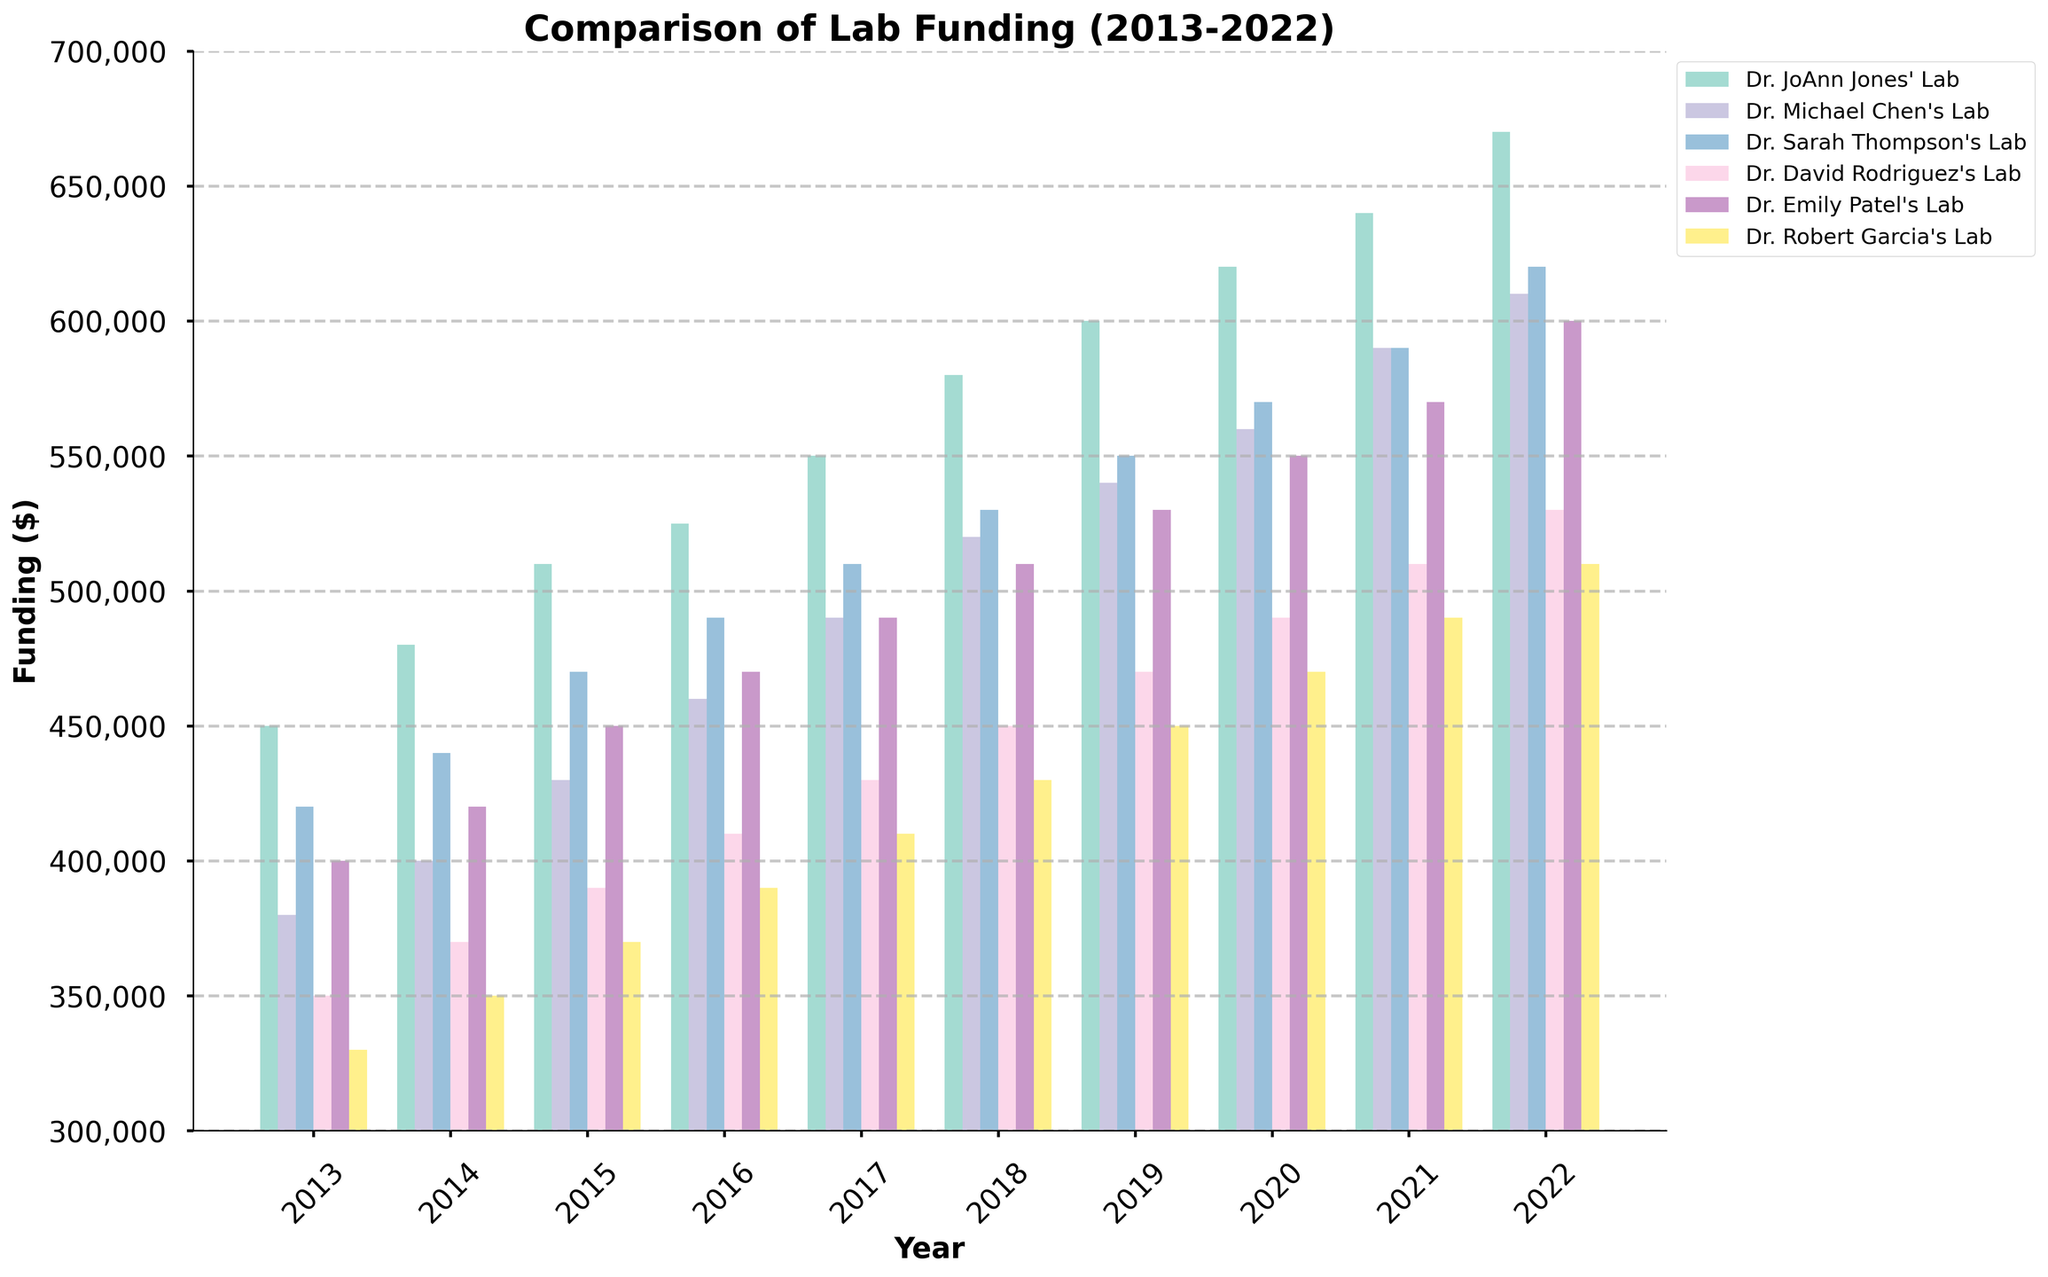Which lab received the highest amount of funding in 2022? To determine this, look at the bars corresponding to 2022 and identify the tallest bar. Dr. JoAnn Jones' Lab has the tallest bar in 2022.
Answer: Dr. JoAnn Jones' Lab Between which two years did Dr. JoAnn Jones' Lab experience the largest increase in funding? Subtract the funding amount for each year from the funding amount for the following year, then find the largest difference. The largest increase is between 2017 and 2018 (580,000 - 550,000 = 30,000).
Answer: 2017 and 2018 What is the average annual funding received by Dr. Robert Garcia's Lab from 2013 to 2022? Sum the funding amounts for each year (330,000 + 350,000 + 370,000 + 390,000 + 410,000 + 430,000 + 450,000 + 470,000 + 490,000 + 510,000 = 4,100,000) and divide by the number of years (10).
Answer: 410,000 How does the funding received by Dr. Michael Chen's Lab in 2020 compare to that of Dr. Emily Patel's Lab in the same year? Look at the bars for 2020 for both labs; Dr. Michael Chen's Lab received 560,000, while Dr. Emily Patel's Lab received 550,000.
Answer: Greater What is the total funding received by Dr. Sarah Thompson's Lab over the entire decade? Sum the funding amounts for each year from 2013 to 2022 (420,000 + 440,000 + 470,000 + 490,000 + 510,000 + 530,000 + 550,000 + 570,000 + 590,000 + 620,000 = 5,190,000).
Answer: 5,190,000 In which year did Dr. David Rodriguez's Lab receive exactly 470,000 in funding? Look at the bars for Dr. David Rodriguez's Lab and identify the year corresponding to the bar height of 470,000. It is in 2019.
Answer: 2019 How did the funding trend of Dr. JoAnn Jones' Lab change from 2013 to 2022? Observe the progression of the bars for Dr. JoAnn Jones' Lab. The height consistently increases each year from 450,000 in 2013 to 670,000 in 2022.
Answer: Consistently increasing Which lab has the least amount of funding in 2015, and what is the amount? Look at the bars corresponding to 2015 and identify the shortest bar. Dr. Robert Garcia's Lab has the shortest bar, with funding amounting to 370,000.
Answer: Dr. Robert Garcia's Lab, 370,000 